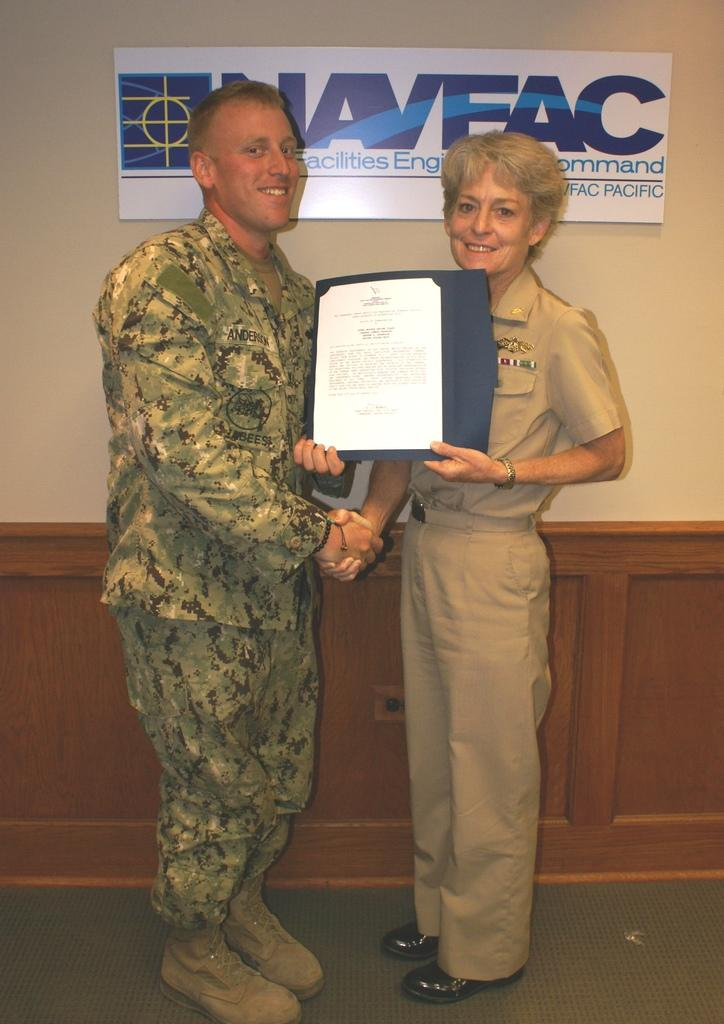Provide a one-sentence caption for the provided image. A man with Anderson on his name tag receives an award. 